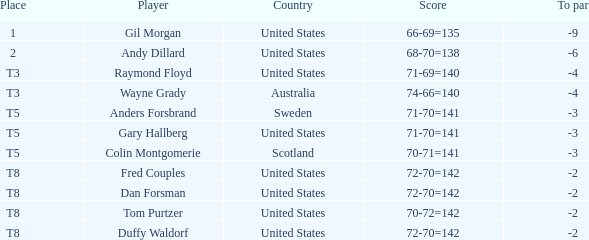What is the To par of the Player with a Score of 70-71=141? -3.0. Would you be able to parse every entry in this table? {'header': ['Place', 'Player', 'Country', 'Score', 'To par'], 'rows': [['1', 'Gil Morgan', 'United States', '66-69=135', '-9'], ['2', 'Andy Dillard', 'United States', '68-70=138', '-6'], ['T3', 'Raymond Floyd', 'United States', '71-69=140', '-4'], ['T3', 'Wayne Grady', 'Australia', '74-66=140', '-4'], ['T5', 'Anders Forsbrand', 'Sweden', '71-70=141', '-3'], ['T5', 'Gary Hallberg', 'United States', '71-70=141', '-3'], ['T5', 'Colin Montgomerie', 'Scotland', '70-71=141', '-3'], ['T8', 'Fred Couples', 'United States', '72-70=142', '-2'], ['T8', 'Dan Forsman', 'United States', '72-70=142', '-2'], ['T8', 'Tom Purtzer', 'United States', '70-72=142', '-2'], ['T8', 'Duffy Waldorf', 'United States', '72-70=142', '-2']]} 